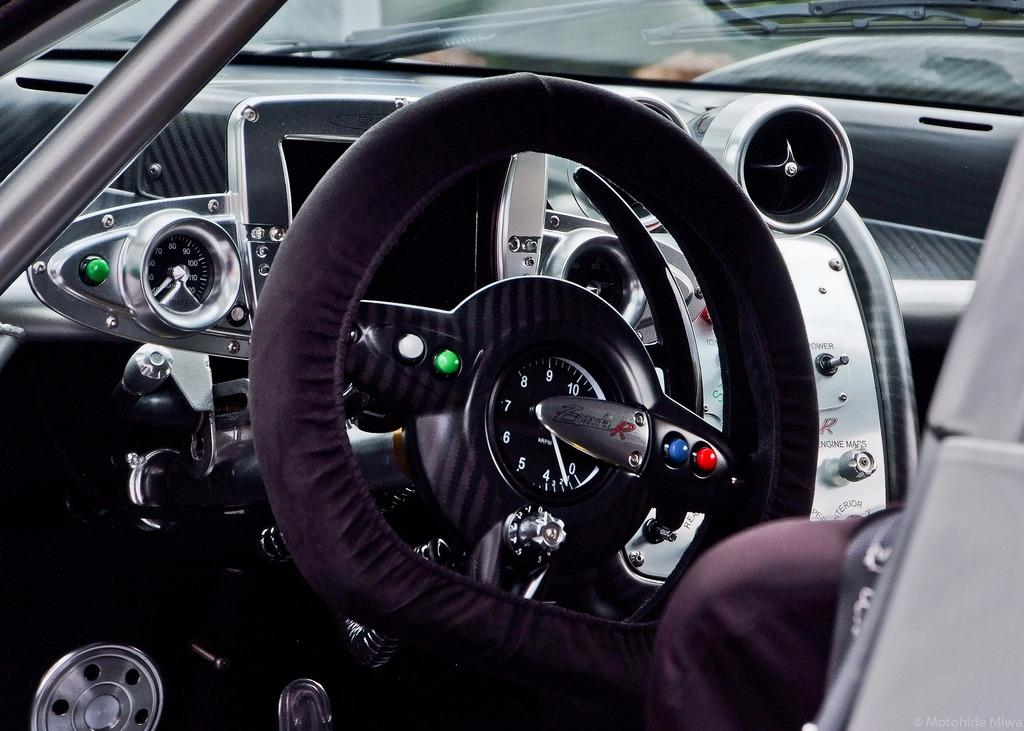What part of a car can be seen in the image? The steering and speedometer of a car are visible in the image. What feature of the car's dashboard is shown? The speedometer of a car is visible in the image. What part of the car allows the driver to see the road ahead? The windshield of a car is present in the image. What type of country is depicted in the image? There is no country depicted in the image; it features a car's steering, speedometer, and windshield. How does the driver jump out of the car in the image? There is no driver or jumping action depicted in the image; it only shows the car's steering, speedometer, and windshield. 